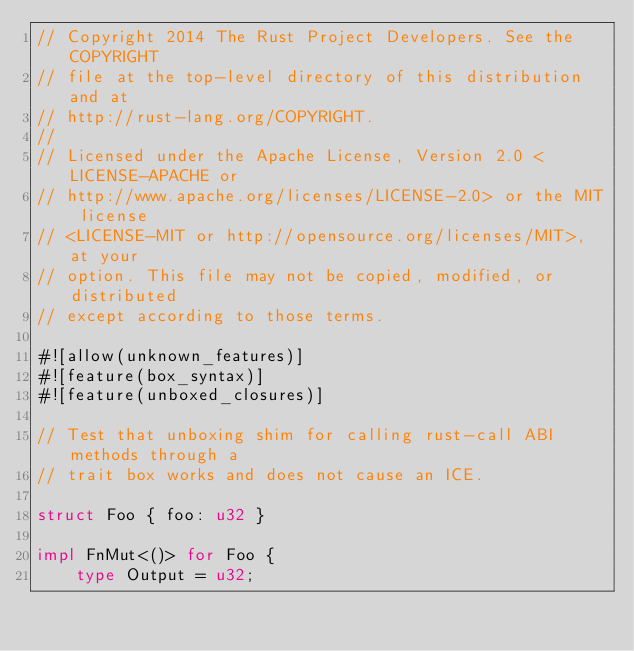<code> <loc_0><loc_0><loc_500><loc_500><_Rust_>// Copyright 2014 The Rust Project Developers. See the COPYRIGHT
// file at the top-level directory of this distribution and at
// http://rust-lang.org/COPYRIGHT.
//
// Licensed under the Apache License, Version 2.0 <LICENSE-APACHE or
// http://www.apache.org/licenses/LICENSE-2.0> or the MIT license
// <LICENSE-MIT or http://opensource.org/licenses/MIT>, at your
// option. This file may not be copied, modified, or distributed
// except according to those terms.

#![allow(unknown_features)]
#![feature(box_syntax)]
#![feature(unboxed_closures)]

// Test that unboxing shim for calling rust-call ABI methods through a
// trait box works and does not cause an ICE.

struct Foo { foo: u32 }

impl FnMut<()> for Foo {
    type Output = u32;</code> 